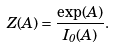Convert formula to latex. <formula><loc_0><loc_0><loc_500><loc_500>Z ( A ) = \frac { \exp ( A ) } { I _ { 0 } ( A ) } .</formula> 